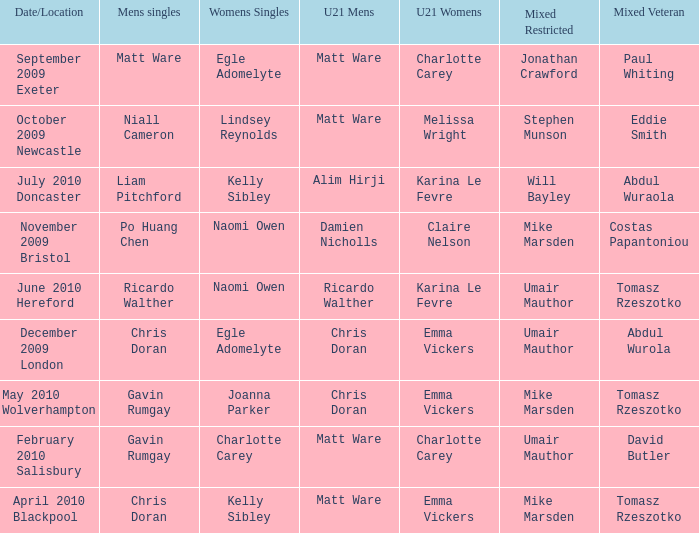When Naomi Owen won the Womens Singles and Ricardo Walther won the Mens Singles, who won the mixed veteran? Tomasz Rzeszotko. 